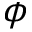<formula> <loc_0><loc_0><loc_500><loc_500>\phi</formula> 